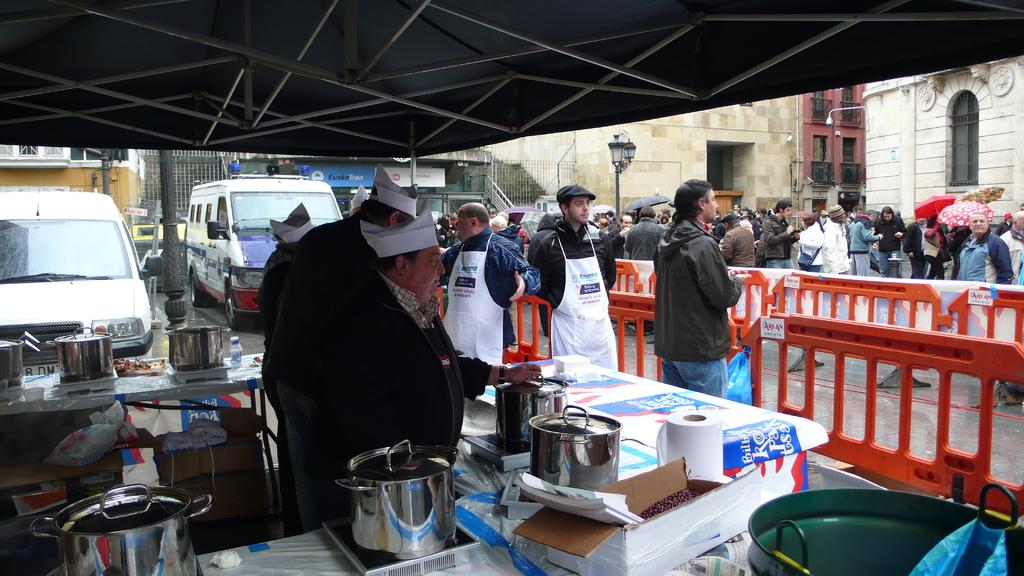How many people are in the group visible in the image? There is a group of people in the image, but the exact number cannot be determined from the provided facts. What is the purpose of the fence in the image? The purpose of the fence in the image cannot be determined from the provided facts. What are the bowls used for in the image? The purpose of the bowls in the image cannot be determined from the provided facts. What types of vehicles can be seen on the road in the image? Vehicles are visible on the road in the image, but the specific types cannot be determined from the provided facts. What can be seen in the background of the image? There are buildings in the background of the image. Where is the scarecrow located in the image? There is no scarecrow present in the image. What type of error can be seen in the image? There is no error present in the image. 